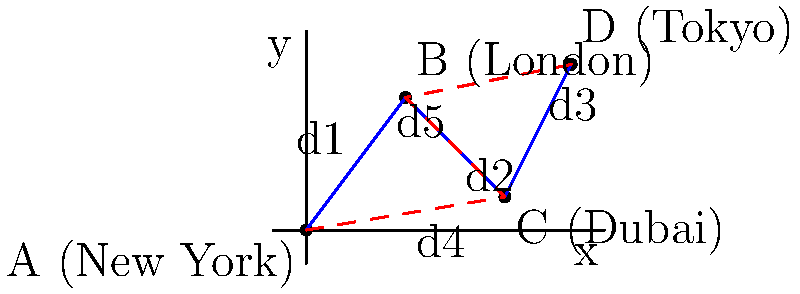In a global trade network, four major financial hubs are represented on a coordinate plane: New York (0,0), London (3,4), Dubai (6,1), and Tokyo (8,5). Two potential trade routes are proposed:

1. New York → London → Dubai → Tokyo (solid blue line)
2. New York → Dubai → London → Tokyo (dashed red line)

Which route minimizes the total distance traveled, and by how much? Assume the distance between points is calculated using the Euclidean distance formula. Express your answer as a decimal rounded to two places. To solve this problem, we need to calculate the total distance for each route and compare them:

1. Calculate distances between points using the Euclidean distance formula:
   $d = \sqrt{(x_2-x_1)^2 + (y_2-y_1)^2}$

   d1 (NY to London): $\sqrt{(3-0)^2 + (4-0)^2} = 5$
   d2 (London to Dubai): $\sqrt{(6-3)^2 + (1-4)^2} = 5$
   d3 (Dubai to Tokyo): $\sqrt{(8-6)^2 + (5-1)^2} = 4.47$
   d4 (NY to Dubai): $\sqrt{(6-0)^2 + (1-0)^2} = 6.08$
   d5 (Dubai to London): $\sqrt{(3-6)^2 + (4-1)^2} = 5$

2. Calculate total distance for Route 1 (blue):
   Total1 = d1 + d2 + d3 = 5 + 5 + 4.47 = 14.47

3. Calculate total distance for Route 2 (red):
   Total2 = d4 + d5 + d3 = 6.08 + 5 + 4.47 = 15.55

4. Compare the routes:
   Difference = Total2 - Total1 = 15.55 - 14.47 = 1.08

Route 1 (blue) is shorter by 1.08 units.
Answer: Route 1 (blue) is shorter by 1.08 units. 